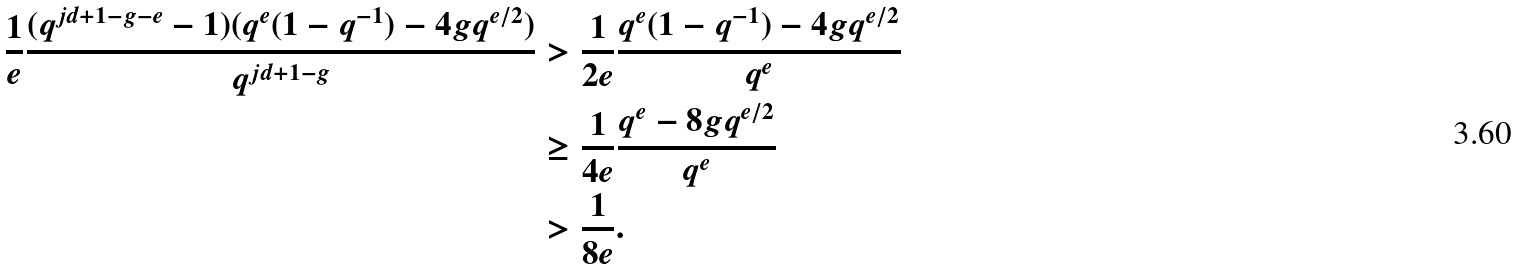Convert formula to latex. <formula><loc_0><loc_0><loc_500><loc_500>\frac { 1 } { e } \frac { ( q ^ { j d + 1 - g - e } - 1 ) ( q ^ { e } ( 1 - q ^ { - 1 } ) - 4 g q ^ { e / 2 } ) } { q ^ { j d + 1 - g } } & > \frac { 1 } { 2 e } \frac { q ^ { e } ( 1 - q ^ { - 1 } ) - 4 g q ^ { e / 2 } } { q ^ { e } } \\ & \geq \frac { 1 } { 4 e } \frac { q ^ { e } - 8 g q ^ { e / 2 } } { q ^ { e } } \\ & > \frac { 1 } { 8 e } .</formula> 